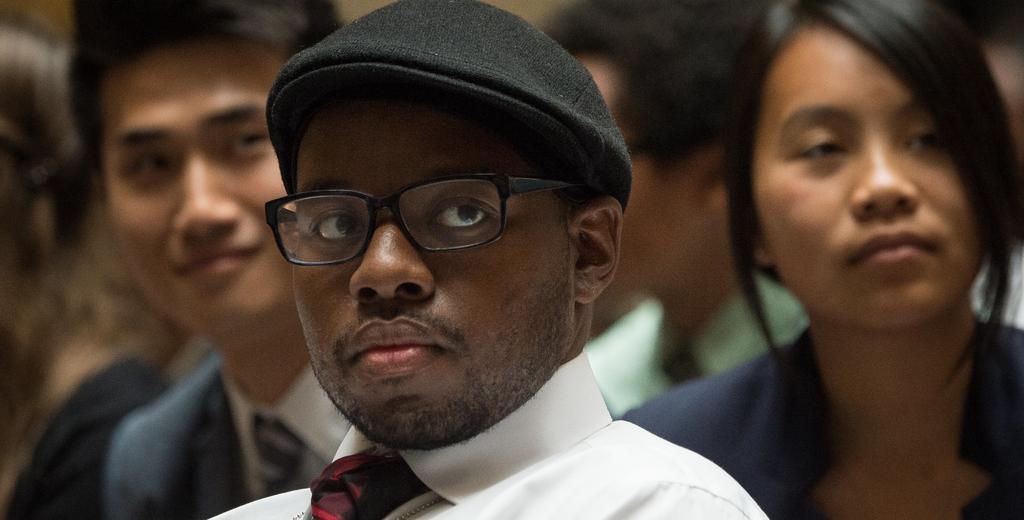How would you summarize this image in a sentence or two? In the picture I can see people among them the man in the front of the image is wearing a cap, spectacles, a white color shirt and a tie. The background of the image is blurred. 